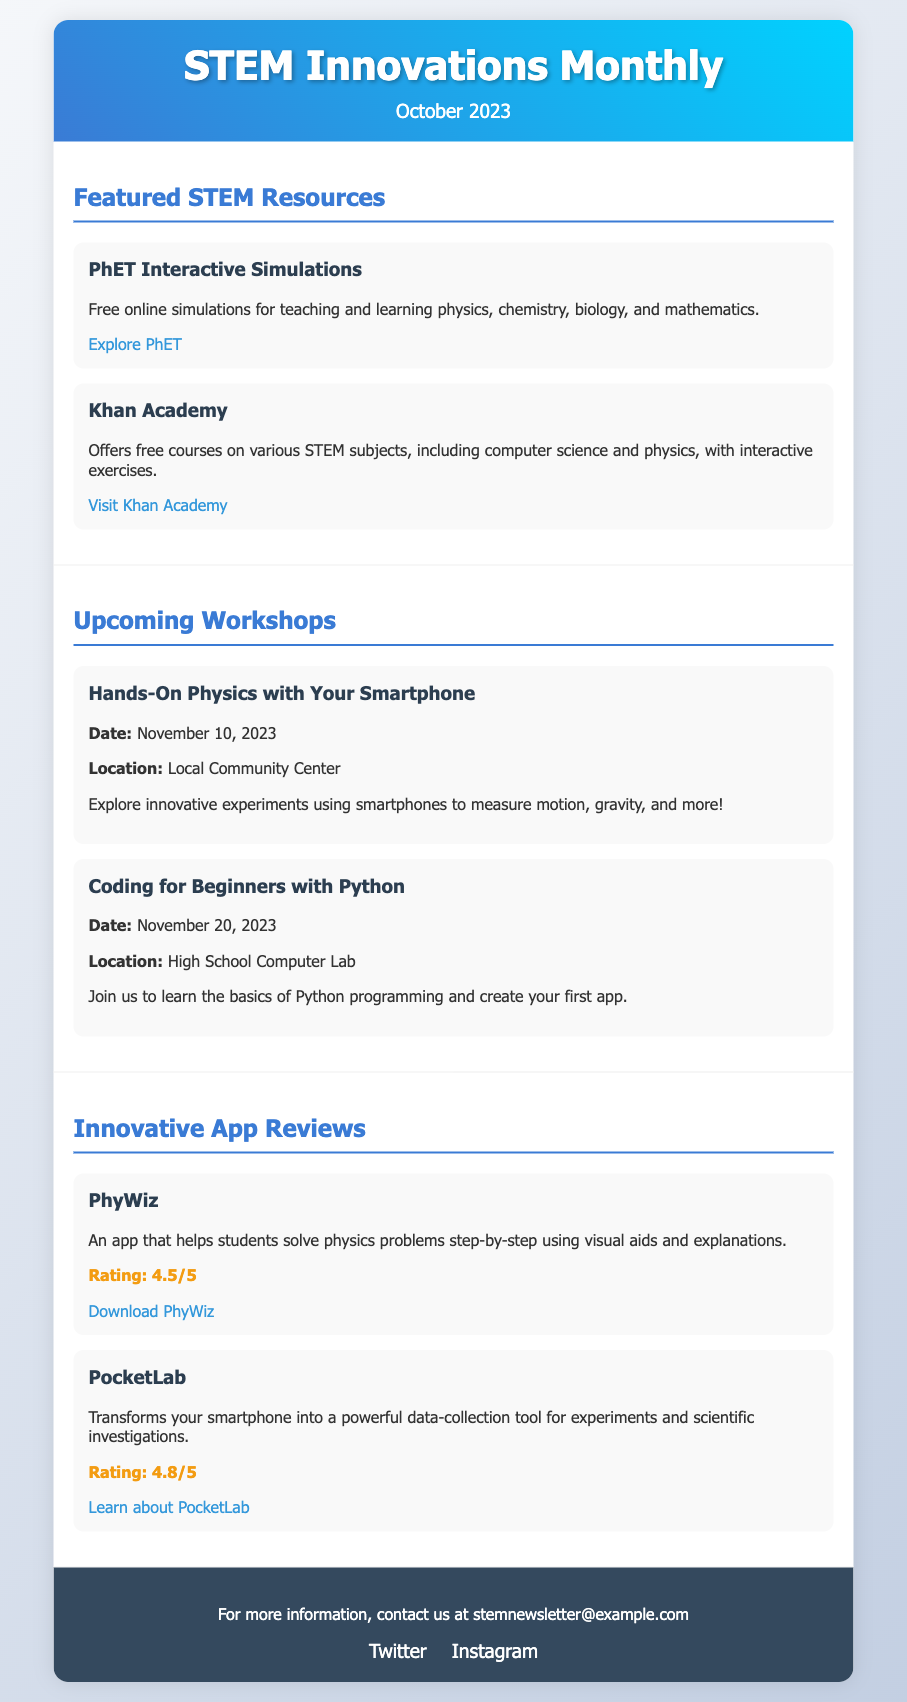what is the title of the newsletter? The title of the newsletter is provided in the header section of the document.
Answer: STEM Innovations Monthly what month and year is this issue from? The month and year are specified immediately under the title in the header section.
Answer: October 2023 how many featured STEM resources are listed? The number of resources can be counted in the Featured STEM Resources section of the document.
Answer: 2 what is the date of the first upcoming workshop? The date is mentioned directly within the Hands-On Physics workshop's details.
Answer: November 10, 2023 what app is rated 4.8 out of 5? The rating is provided under the app review section for PocketLab, indicating its high rating.
Answer: PocketLab what location is the Coding for Beginners workshop held? The workshop's location is mentioned in the details of the workshop in the document.
Answer: High School Computer Lab which innovation does the PhyWiz app help students with? The app's purpose is briefly described in the app review section regarding the type of problems it addresses.
Answer: Physics problems what is the main theme of the workshops listed? The workshops focus on practical applications of STEM concepts, as seen in the descriptions.
Answer: Innovative experiments and programming how can readers contact the newsletter team? The contact information is provided in the footer section of the document.
Answer: stemnewsletter@example.com 